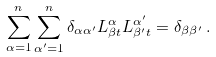Convert formula to latex. <formula><loc_0><loc_0><loc_500><loc_500>\sum _ { \alpha = 1 } ^ { n } \sum _ { \alpha ^ { \prime } = 1 } ^ { n } \delta _ { \alpha \alpha ^ { \prime } } L _ { \beta t } ^ { \alpha } L _ { \beta ^ { \prime } t } ^ { \alpha ^ { \prime } } = \delta _ { \beta \beta ^ { \prime } } \, .</formula> 